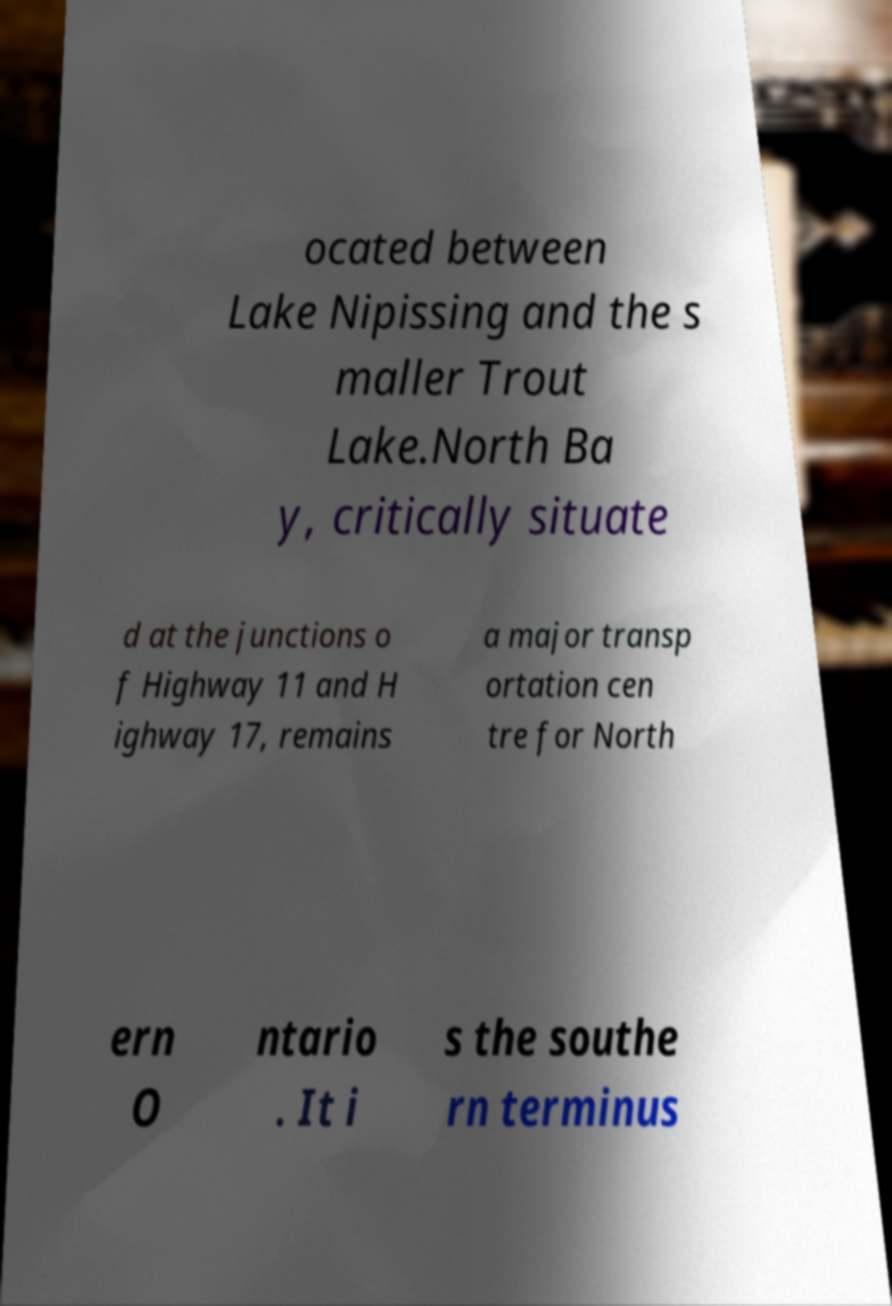Please read and relay the text visible in this image. What does it say? ocated between Lake Nipissing and the s maller Trout Lake.North Ba y, critically situate d at the junctions o f Highway 11 and H ighway 17, remains a major transp ortation cen tre for North ern O ntario . It i s the southe rn terminus 